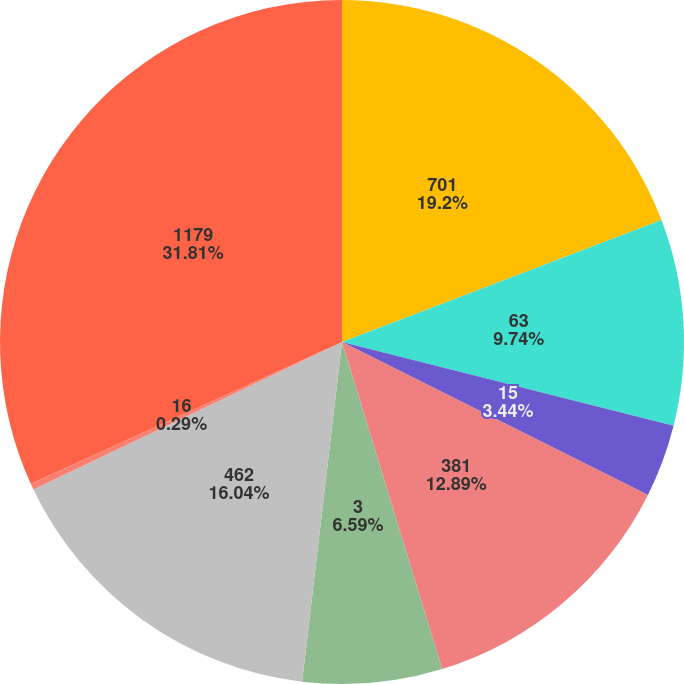<chart> <loc_0><loc_0><loc_500><loc_500><pie_chart><fcel>701<fcel>63<fcel>15<fcel>381<fcel>3<fcel>462<fcel>16<fcel>1179<nl><fcel>19.19%<fcel>9.74%<fcel>3.44%<fcel>12.89%<fcel>6.59%<fcel>16.04%<fcel>0.29%<fcel>31.8%<nl></chart> 